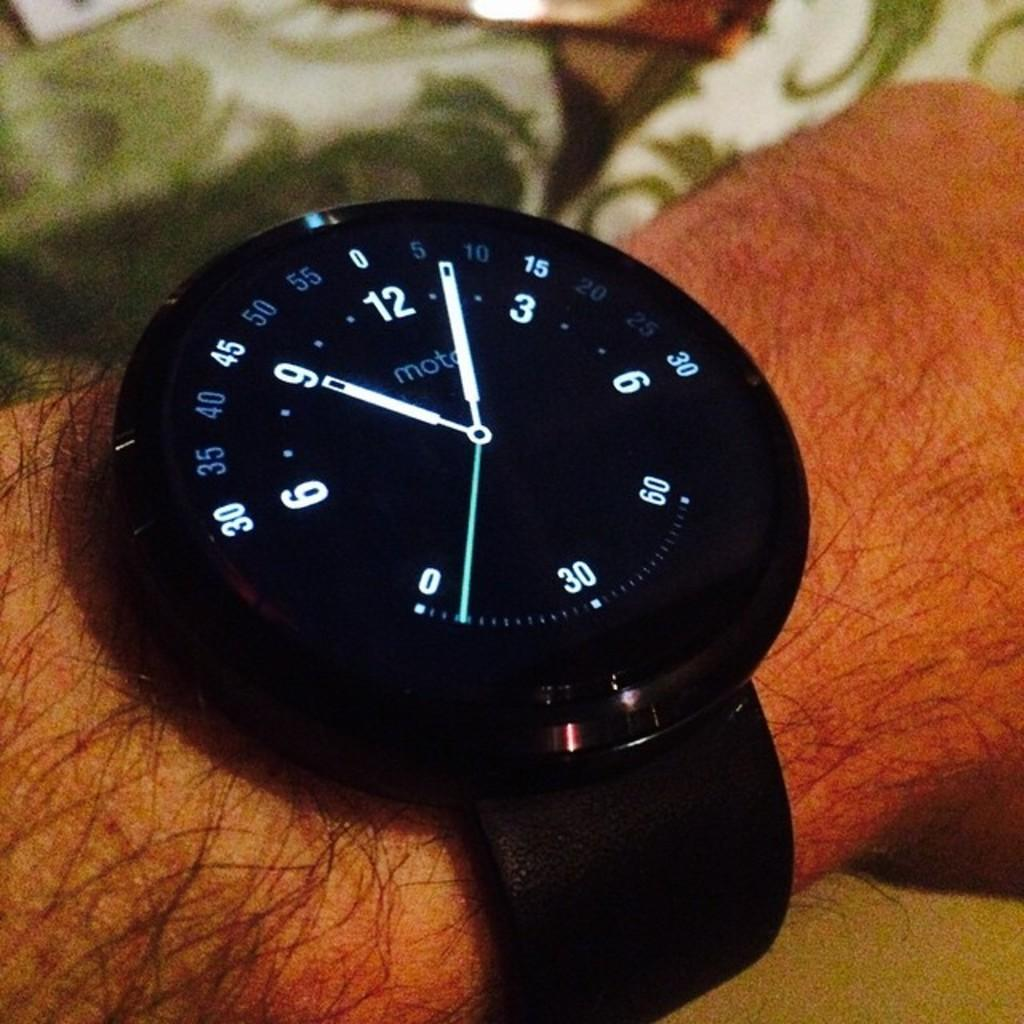<image>
Summarize the visual content of the image. a moto watch face set at the time 9:06 with green second hand 